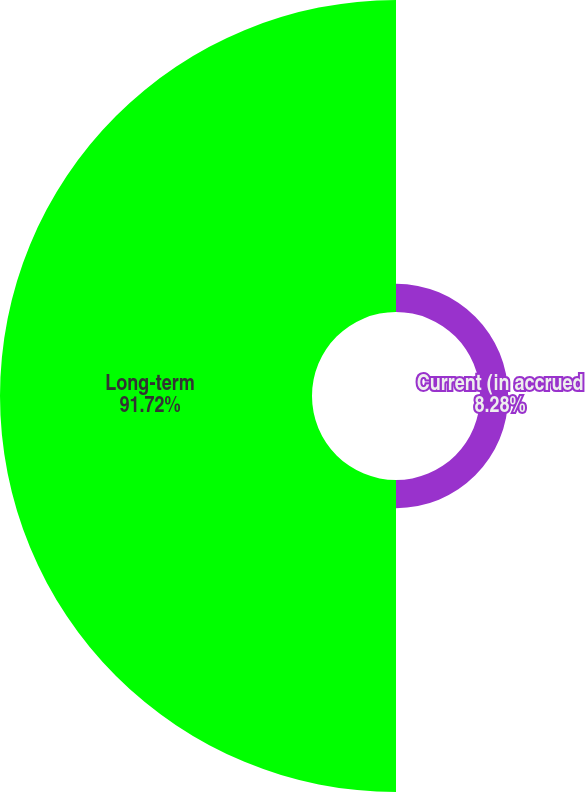Convert chart. <chart><loc_0><loc_0><loc_500><loc_500><pie_chart><fcel>Current (in accrued<fcel>Long-term<nl><fcel>8.28%<fcel>91.72%<nl></chart> 